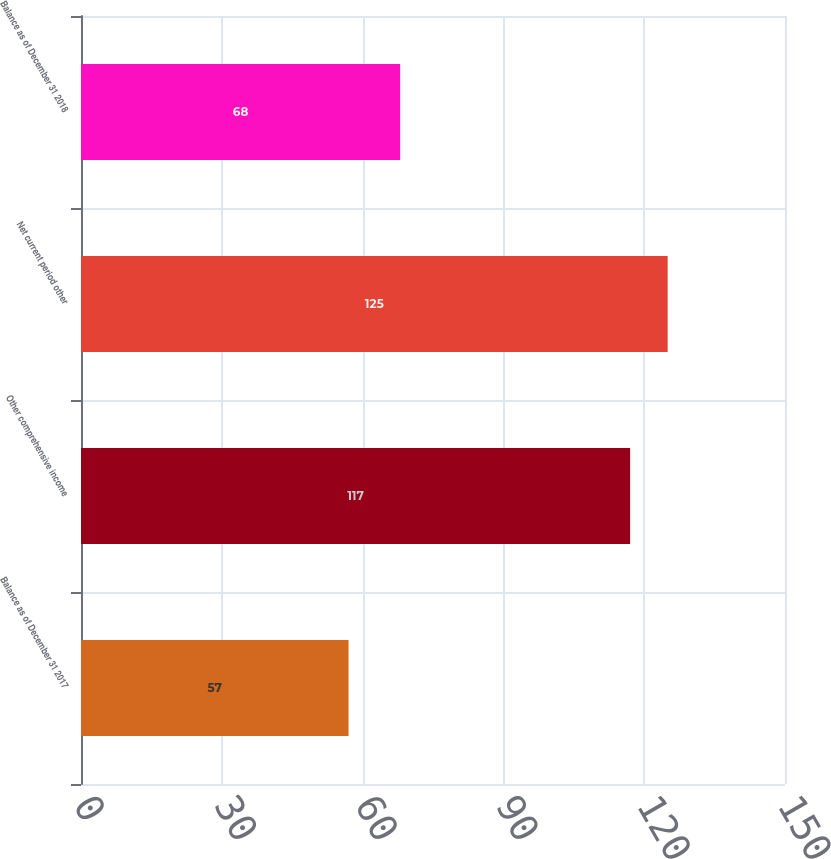Convert chart to OTSL. <chart><loc_0><loc_0><loc_500><loc_500><bar_chart><fcel>Balance as of December 31 2017<fcel>Other comprehensive income<fcel>Net current period other<fcel>Balance as of December 31 2018<nl><fcel>57<fcel>117<fcel>125<fcel>68<nl></chart> 